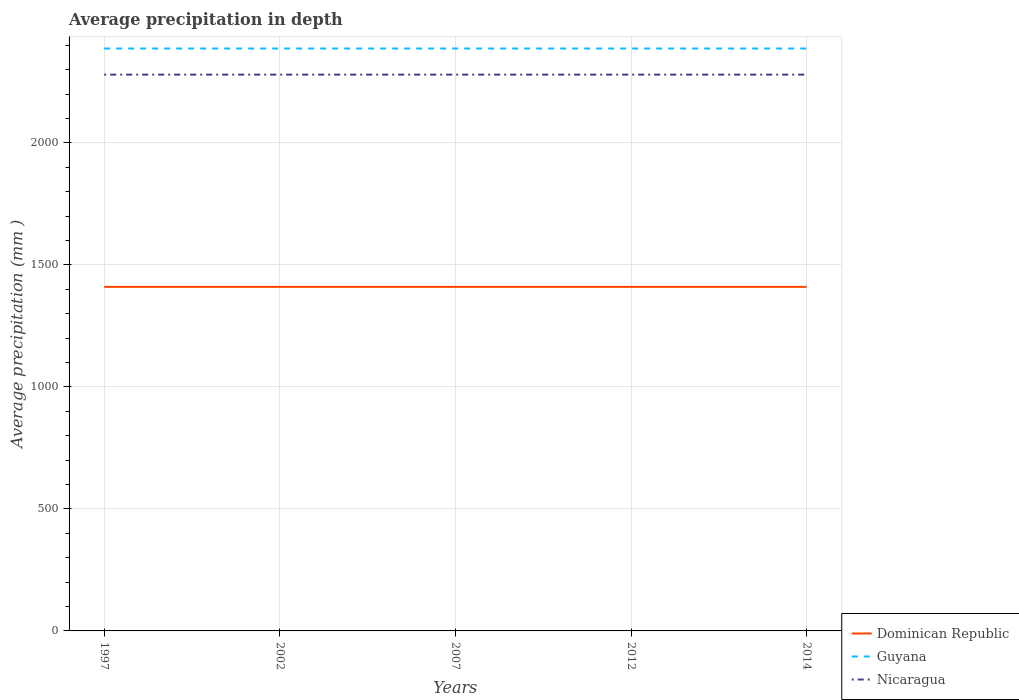How many different coloured lines are there?
Give a very brief answer. 3. Is the number of lines equal to the number of legend labels?
Your answer should be very brief. Yes. Across all years, what is the maximum average precipitation in Nicaragua?
Keep it short and to the point. 2280. In which year was the average precipitation in Guyana maximum?
Offer a terse response. 1997. What is the difference between the highest and the second highest average precipitation in Nicaragua?
Provide a succinct answer. 0. How many years are there in the graph?
Offer a terse response. 5. Are the values on the major ticks of Y-axis written in scientific E-notation?
Provide a succinct answer. No. Does the graph contain any zero values?
Offer a terse response. No. Does the graph contain grids?
Your answer should be compact. Yes. What is the title of the graph?
Your response must be concise. Average precipitation in depth. What is the label or title of the X-axis?
Your answer should be very brief. Years. What is the label or title of the Y-axis?
Make the answer very short. Average precipitation (mm ). What is the Average precipitation (mm ) in Dominican Republic in 1997?
Provide a succinct answer. 1410. What is the Average precipitation (mm ) of Guyana in 1997?
Keep it short and to the point. 2387. What is the Average precipitation (mm ) of Nicaragua in 1997?
Offer a very short reply. 2280. What is the Average precipitation (mm ) of Dominican Republic in 2002?
Offer a terse response. 1410. What is the Average precipitation (mm ) in Guyana in 2002?
Your answer should be very brief. 2387. What is the Average precipitation (mm ) in Nicaragua in 2002?
Your answer should be compact. 2280. What is the Average precipitation (mm ) of Dominican Republic in 2007?
Your answer should be compact. 1410. What is the Average precipitation (mm ) in Guyana in 2007?
Offer a terse response. 2387. What is the Average precipitation (mm ) in Nicaragua in 2007?
Make the answer very short. 2280. What is the Average precipitation (mm ) in Dominican Republic in 2012?
Your answer should be very brief. 1410. What is the Average precipitation (mm ) of Guyana in 2012?
Ensure brevity in your answer.  2387. What is the Average precipitation (mm ) of Nicaragua in 2012?
Give a very brief answer. 2280. What is the Average precipitation (mm ) of Dominican Republic in 2014?
Provide a succinct answer. 1410. What is the Average precipitation (mm ) of Guyana in 2014?
Your answer should be compact. 2387. What is the Average precipitation (mm ) in Nicaragua in 2014?
Provide a succinct answer. 2280. Across all years, what is the maximum Average precipitation (mm ) of Dominican Republic?
Provide a short and direct response. 1410. Across all years, what is the maximum Average precipitation (mm ) in Guyana?
Provide a short and direct response. 2387. Across all years, what is the maximum Average precipitation (mm ) in Nicaragua?
Offer a terse response. 2280. Across all years, what is the minimum Average precipitation (mm ) in Dominican Republic?
Your answer should be compact. 1410. Across all years, what is the minimum Average precipitation (mm ) in Guyana?
Provide a succinct answer. 2387. Across all years, what is the minimum Average precipitation (mm ) in Nicaragua?
Offer a very short reply. 2280. What is the total Average precipitation (mm ) in Dominican Republic in the graph?
Keep it short and to the point. 7050. What is the total Average precipitation (mm ) of Guyana in the graph?
Your response must be concise. 1.19e+04. What is the total Average precipitation (mm ) of Nicaragua in the graph?
Make the answer very short. 1.14e+04. What is the difference between the Average precipitation (mm ) of Dominican Republic in 1997 and that in 2002?
Give a very brief answer. 0. What is the difference between the Average precipitation (mm ) in Nicaragua in 1997 and that in 2002?
Your answer should be very brief. 0. What is the difference between the Average precipitation (mm ) of Dominican Republic in 1997 and that in 2007?
Provide a short and direct response. 0. What is the difference between the Average precipitation (mm ) in Guyana in 1997 and that in 2012?
Your answer should be compact. 0. What is the difference between the Average precipitation (mm ) in Nicaragua in 1997 and that in 2012?
Ensure brevity in your answer.  0. What is the difference between the Average precipitation (mm ) in Dominican Republic in 1997 and that in 2014?
Make the answer very short. 0. What is the difference between the Average precipitation (mm ) in Dominican Republic in 2002 and that in 2007?
Give a very brief answer. 0. What is the difference between the Average precipitation (mm ) of Guyana in 2002 and that in 2007?
Your answer should be compact. 0. What is the difference between the Average precipitation (mm ) of Nicaragua in 2002 and that in 2007?
Make the answer very short. 0. What is the difference between the Average precipitation (mm ) in Dominican Republic in 2002 and that in 2012?
Make the answer very short. 0. What is the difference between the Average precipitation (mm ) in Nicaragua in 2002 and that in 2012?
Offer a very short reply. 0. What is the difference between the Average precipitation (mm ) of Guyana in 2002 and that in 2014?
Your answer should be compact. 0. What is the difference between the Average precipitation (mm ) of Nicaragua in 2002 and that in 2014?
Ensure brevity in your answer.  0. What is the difference between the Average precipitation (mm ) in Dominican Republic in 2007 and that in 2012?
Your answer should be compact. 0. What is the difference between the Average precipitation (mm ) of Guyana in 2007 and that in 2012?
Keep it short and to the point. 0. What is the difference between the Average precipitation (mm ) of Nicaragua in 2007 and that in 2012?
Keep it short and to the point. 0. What is the difference between the Average precipitation (mm ) of Dominican Republic in 2007 and that in 2014?
Provide a short and direct response. 0. What is the difference between the Average precipitation (mm ) of Guyana in 2007 and that in 2014?
Offer a terse response. 0. What is the difference between the Average precipitation (mm ) of Dominican Republic in 2012 and that in 2014?
Keep it short and to the point. 0. What is the difference between the Average precipitation (mm ) in Dominican Republic in 1997 and the Average precipitation (mm ) in Guyana in 2002?
Your answer should be compact. -977. What is the difference between the Average precipitation (mm ) of Dominican Republic in 1997 and the Average precipitation (mm ) of Nicaragua in 2002?
Your response must be concise. -870. What is the difference between the Average precipitation (mm ) in Guyana in 1997 and the Average precipitation (mm ) in Nicaragua in 2002?
Provide a short and direct response. 107. What is the difference between the Average precipitation (mm ) in Dominican Republic in 1997 and the Average precipitation (mm ) in Guyana in 2007?
Ensure brevity in your answer.  -977. What is the difference between the Average precipitation (mm ) in Dominican Republic in 1997 and the Average precipitation (mm ) in Nicaragua in 2007?
Ensure brevity in your answer.  -870. What is the difference between the Average precipitation (mm ) of Guyana in 1997 and the Average precipitation (mm ) of Nicaragua in 2007?
Make the answer very short. 107. What is the difference between the Average precipitation (mm ) of Dominican Republic in 1997 and the Average precipitation (mm ) of Guyana in 2012?
Offer a very short reply. -977. What is the difference between the Average precipitation (mm ) in Dominican Republic in 1997 and the Average precipitation (mm ) in Nicaragua in 2012?
Ensure brevity in your answer.  -870. What is the difference between the Average precipitation (mm ) of Guyana in 1997 and the Average precipitation (mm ) of Nicaragua in 2012?
Give a very brief answer. 107. What is the difference between the Average precipitation (mm ) of Dominican Republic in 1997 and the Average precipitation (mm ) of Guyana in 2014?
Your response must be concise. -977. What is the difference between the Average precipitation (mm ) of Dominican Republic in 1997 and the Average precipitation (mm ) of Nicaragua in 2014?
Your answer should be very brief. -870. What is the difference between the Average precipitation (mm ) in Guyana in 1997 and the Average precipitation (mm ) in Nicaragua in 2014?
Your response must be concise. 107. What is the difference between the Average precipitation (mm ) of Dominican Republic in 2002 and the Average precipitation (mm ) of Guyana in 2007?
Keep it short and to the point. -977. What is the difference between the Average precipitation (mm ) of Dominican Republic in 2002 and the Average precipitation (mm ) of Nicaragua in 2007?
Keep it short and to the point. -870. What is the difference between the Average precipitation (mm ) of Guyana in 2002 and the Average precipitation (mm ) of Nicaragua in 2007?
Your answer should be very brief. 107. What is the difference between the Average precipitation (mm ) in Dominican Republic in 2002 and the Average precipitation (mm ) in Guyana in 2012?
Offer a very short reply. -977. What is the difference between the Average precipitation (mm ) of Dominican Republic in 2002 and the Average precipitation (mm ) of Nicaragua in 2012?
Your response must be concise. -870. What is the difference between the Average precipitation (mm ) in Guyana in 2002 and the Average precipitation (mm ) in Nicaragua in 2012?
Your answer should be very brief. 107. What is the difference between the Average precipitation (mm ) in Dominican Republic in 2002 and the Average precipitation (mm ) in Guyana in 2014?
Your response must be concise. -977. What is the difference between the Average precipitation (mm ) in Dominican Republic in 2002 and the Average precipitation (mm ) in Nicaragua in 2014?
Give a very brief answer. -870. What is the difference between the Average precipitation (mm ) of Guyana in 2002 and the Average precipitation (mm ) of Nicaragua in 2014?
Provide a succinct answer. 107. What is the difference between the Average precipitation (mm ) in Dominican Republic in 2007 and the Average precipitation (mm ) in Guyana in 2012?
Offer a terse response. -977. What is the difference between the Average precipitation (mm ) of Dominican Republic in 2007 and the Average precipitation (mm ) of Nicaragua in 2012?
Provide a short and direct response. -870. What is the difference between the Average precipitation (mm ) in Guyana in 2007 and the Average precipitation (mm ) in Nicaragua in 2012?
Provide a short and direct response. 107. What is the difference between the Average precipitation (mm ) of Dominican Republic in 2007 and the Average precipitation (mm ) of Guyana in 2014?
Provide a short and direct response. -977. What is the difference between the Average precipitation (mm ) of Dominican Republic in 2007 and the Average precipitation (mm ) of Nicaragua in 2014?
Provide a succinct answer. -870. What is the difference between the Average precipitation (mm ) in Guyana in 2007 and the Average precipitation (mm ) in Nicaragua in 2014?
Keep it short and to the point. 107. What is the difference between the Average precipitation (mm ) of Dominican Republic in 2012 and the Average precipitation (mm ) of Guyana in 2014?
Make the answer very short. -977. What is the difference between the Average precipitation (mm ) in Dominican Republic in 2012 and the Average precipitation (mm ) in Nicaragua in 2014?
Make the answer very short. -870. What is the difference between the Average precipitation (mm ) of Guyana in 2012 and the Average precipitation (mm ) of Nicaragua in 2014?
Your response must be concise. 107. What is the average Average precipitation (mm ) of Dominican Republic per year?
Your answer should be very brief. 1410. What is the average Average precipitation (mm ) in Guyana per year?
Make the answer very short. 2387. What is the average Average precipitation (mm ) in Nicaragua per year?
Offer a terse response. 2280. In the year 1997, what is the difference between the Average precipitation (mm ) of Dominican Republic and Average precipitation (mm ) of Guyana?
Provide a short and direct response. -977. In the year 1997, what is the difference between the Average precipitation (mm ) in Dominican Republic and Average precipitation (mm ) in Nicaragua?
Ensure brevity in your answer.  -870. In the year 1997, what is the difference between the Average precipitation (mm ) of Guyana and Average precipitation (mm ) of Nicaragua?
Keep it short and to the point. 107. In the year 2002, what is the difference between the Average precipitation (mm ) of Dominican Republic and Average precipitation (mm ) of Guyana?
Provide a succinct answer. -977. In the year 2002, what is the difference between the Average precipitation (mm ) of Dominican Republic and Average precipitation (mm ) of Nicaragua?
Offer a terse response. -870. In the year 2002, what is the difference between the Average precipitation (mm ) of Guyana and Average precipitation (mm ) of Nicaragua?
Keep it short and to the point. 107. In the year 2007, what is the difference between the Average precipitation (mm ) of Dominican Republic and Average precipitation (mm ) of Guyana?
Ensure brevity in your answer.  -977. In the year 2007, what is the difference between the Average precipitation (mm ) in Dominican Republic and Average precipitation (mm ) in Nicaragua?
Offer a terse response. -870. In the year 2007, what is the difference between the Average precipitation (mm ) of Guyana and Average precipitation (mm ) of Nicaragua?
Offer a very short reply. 107. In the year 2012, what is the difference between the Average precipitation (mm ) of Dominican Republic and Average precipitation (mm ) of Guyana?
Provide a succinct answer. -977. In the year 2012, what is the difference between the Average precipitation (mm ) of Dominican Republic and Average precipitation (mm ) of Nicaragua?
Make the answer very short. -870. In the year 2012, what is the difference between the Average precipitation (mm ) in Guyana and Average precipitation (mm ) in Nicaragua?
Make the answer very short. 107. In the year 2014, what is the difference between the Average precipitation (mm ) of Dominican Republic and Average precipitation (mm ) of Guyana?
Provide a succinct answer. -977. In the year 2014, what is the difference between the Average precipitation (mm ) of Dominican Republic and Average precipitation (mm ) of Nicaragua?
Provide a succinct answer. -870. In the year 2014, what is the difference between the Average precipitation (mm ) of Guyana and Average precipitation (mm ) of Nicaragua?
Offer a very short reply. 107. What is the ratio of the Average precipitation (mm ) of Dominican Republic in 1997 to that in 2002?
Provide a succinct answer. 1. What is the ratio of the Average precipitation (mm ) of Guyana in 1997 to that in 2002?
Keep it short and to the point. 1. What is the ratio of the Average precipitation (mm ) in Nicaragua in 1997 to that in 2002?
Offer a very short reply. 1. What is the ratio of the Average precipitation (mm ) of Dominican Republic in 1997 to that in 2007?
Give a very brief answer. 1. What is the ratio of the Average precipitation (mm ) in Guyana in 1997 to that in 2007?
Provide a short and direct response. 1. What is the ratio of the Average precipitation (mm ) in Nicaragua in 1997 to that in 2007?
Give a very brief answer. 1. What is the ratio of the Average precipitation (mm ) of Dominican Republic in 1997 to that in 2012?
Make the answer very short. 1. What is the ratio of the Average precipitation (mm ) in Guyana in 1997 to that in 2012?
Your response must be concise. 1. What is the ratio of the Average precipitation (mm ) of Dominican Republic in 1997 to that in 2014?
Your response must be concise. 1. What is the ratio of the Average precipitation (mm ) in Guyana in 1997 to that in 2014?
Offer a very short reply. 1. What is the ratio of the Average precipitation (mm ) of Dominican Republic in 2002 to that in 2007?
Provide a succinct answer. 1. What is the ratio of the Average precipitation (mm ) in Nicaragua in 2002 to that in 2007?
Ensure brevity in your answer.  1. What is the ratio of the Average precipitation (mm ) in Dominican Republic in 2002 to that in 2012?
Ensure brevity in your answer.  1. What is the ratio of the Average precipitation (mm ) in Guyana in 2002 to that in 2012?
Ensure brevity in your answer.  1. What is the ratio of the Average precipitation (mm ) in Nicaragua in 2002 to that in 2012?
Provide a succinct answer. 1. What is the ratio of the Average precipitation (mm ) of Dominican Republic in 2007 to that in 2012?
Keep it short and to the point. 1. What is the ratio of the Average precipitation (mm ) in Nicaragua in 2007 to that in 2012?
Make the answer very short. 1. What is the ratio of the Average precipitation (mm ) in Dominican Republic in 2007 to that in 2014?
Provide a succinct answer. 1. What is the ratio of the Average precipitation (mm ) in Nicaragua in 2007 to that in 2014?
Provide a succinct answer. 1. What is the ratio of the Average precipitation (mm ) of Nicaragua in 2012 to that in 2014?
Provide a short and direct response. 1. What is the difference between the highest and the second highest Average precipitation (mm ) of Guyana?
Make the answer very short. 0. 